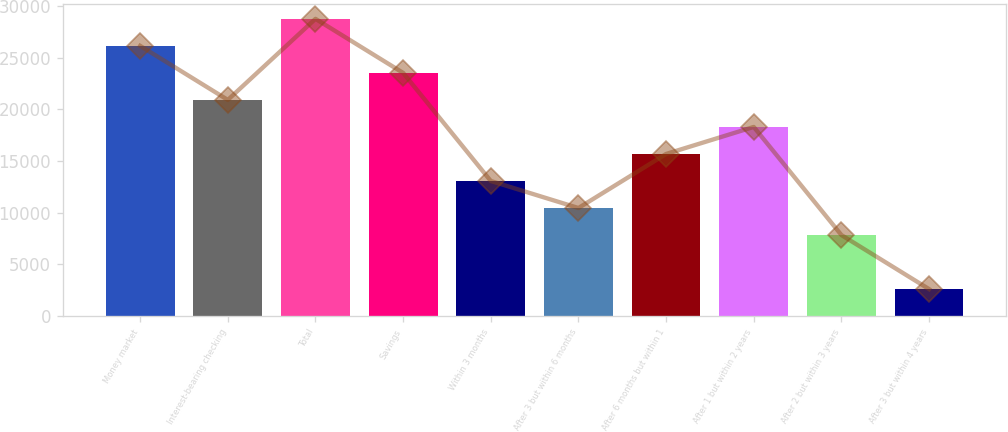Convert chart to OTSL. <chart><loc_0><loc_0><loc_500><loc_500><bar_chart><fcel>Money market<fcel>Interest-bearing checking<fcel>Total<fcel>Savings<fcel>Within 3 months<fcel>After 3 but within 6 months<fcel>After 6 months but within 1<fcel>After 1 but within 2 years<fcel>After 2 but within 3 years<fcel>After 3 but within 4 years<nl><fcel>26138.2<fcel>20911.3<fcel>28751.7<fcel>23524.7<fcel>13070.9<fcel>10457.4<fcel>15684.4<fcel>18297.8<fcel>7843.98<fcel>2617.06<nl></chart> 